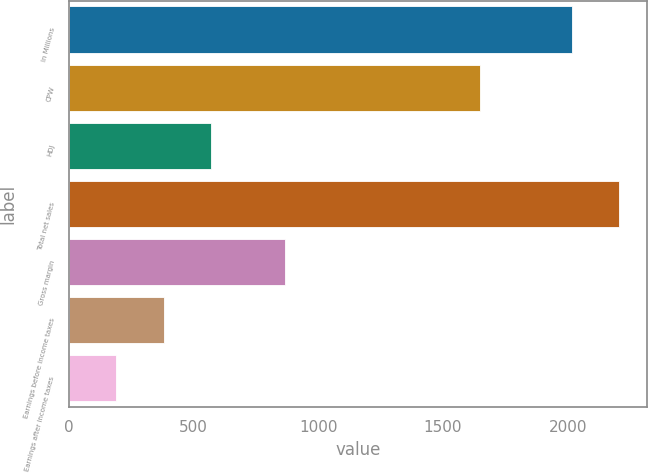<chart> <loc_0><loc_0><loc_500><loc_500><bar_chart><fcel>In Millions<fcel>CPW<fcel>HDJ<fcel>Total net sales<fcel>Gross margin<fcel>Earnings before income taxes<fcel>Earnings after income taxes<nl><fcel>2017<fcel>1648.4<fcel>568.94<fcel>2206.32<fcel>865.9<fcel>379.62<fcel>190.3<nl></chart> 